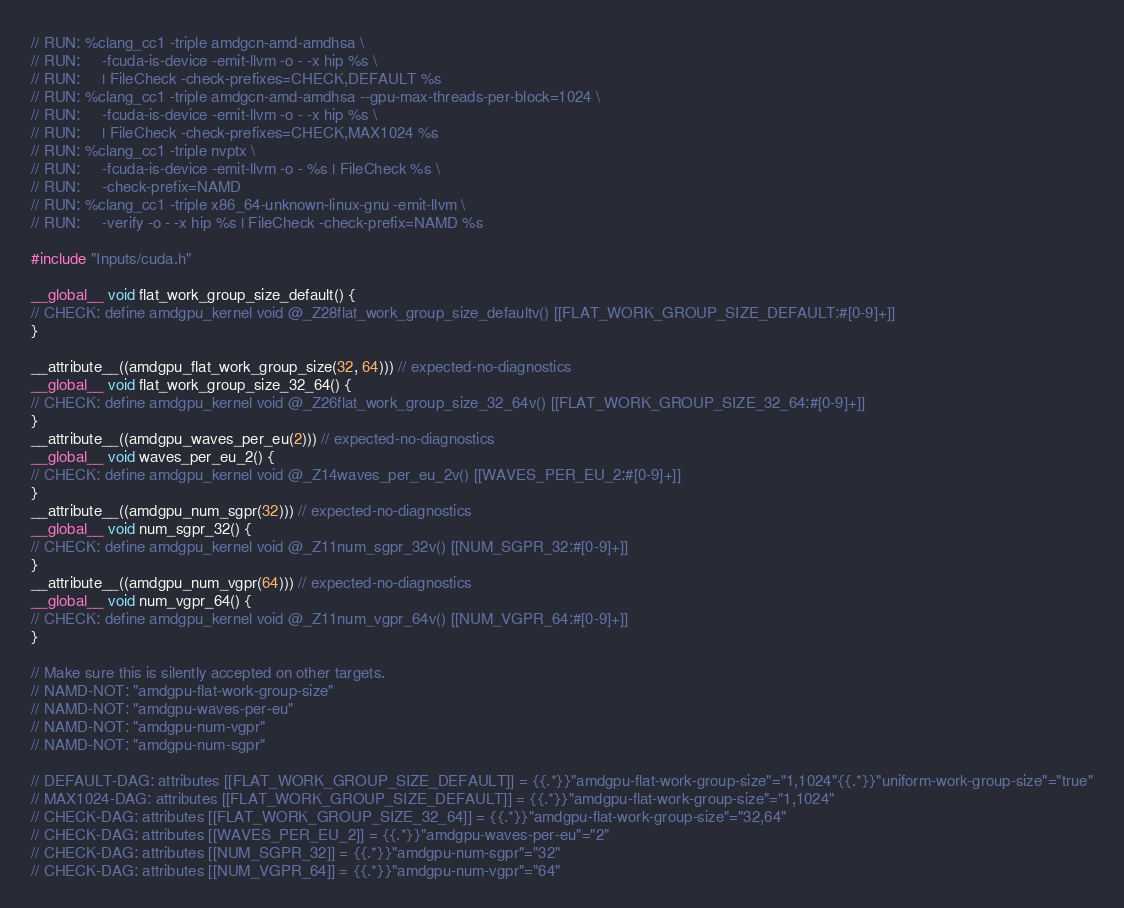<code> <loc_0><loc_0><loc_500><loc_500><_Cuda_>// RUN: %clang_cc1 -triple amdgcn-amd-amdhsa \
// RUN:     -fcuda-is-device -emit-llvm -o - -x hip %s \
// RUN:     | FileCheck -check-prefixes=CHECK,DEFAULT %s
// RUN: %clang_cc1 -triple amdgcn-amd-amdhsa --gpu-max-threads-per-block=1024 \
// RUN:     -fcuda-is-device -emit-llvm -o - -x hip %s \
// RUN:     | FileCheck -check-prefixes=CHECK,MAX1024 %s
// RUN: %clang_cc1 -triple nvptx \
// RUN:     -fcuda-is-device -emit-llvm -o - %s | FileCheck %s \
// RUN:     -check-prefix=NAMD
// RUN: %clang_cc1 -triple x86_64-unknown-linux-gnu -emit-llvm \
// RUN:     -verify -o - -x hip %s | FileCheck -check-prefix=NAMD %s

#include "Inputs/cuda.h"

__global__ void flat_work_group_size_default() {
// CHECK: define amdgpu_kernel void @_Z28flat_work_group_size_defaultv() [[FLAT_WORK_GROUP_SIZE_DEFAULT:#[0-9]+]]
}

__attribute__((amdgpu_flat_work_group_size(32, 64))) // expected-no-diagnostics
__global__ void flat_work_group_size_32_64() {
// CHECK: define amdgpu_kernel void @_Z26flat_work_group_size_32_64v() [[FLAT_WORK_GROUP_SIZE_32_64:#[0-9]+]]
}
__attribute__((amdgpu_waves_per_eu(2))) // expected-no-diagnostics
__global__ void waves_per_eu_2() {
// CHECK: define amdgpu_kernel void @_Z14waves_per_eu_2v() [[WAVES_PER_EU_2:#[0-9]+]]
}
__attribute__((amdgpu_num_sgpr(32))) // expected-no-diagnostics
__global__ void num_sgpr_32() {
// CHECK: define amdgpu_kernel void @_Z11num_sgpr_32v() [[NUM_SGPR_32:#[0-9]+]]
}
__attribute__((amdgpu_num_vgpr(64))) // expected-no-diagnostics
__global__ void num_vgpr_64() {
// CHECK: define amdgpu_kernel void @_Z11num_vgpr_64v() [[NUM_VGPR_64:#[0-9]+]]
}

// Make sure this is silently accepted on other targets.
// NAMD-NOT: "amdgpu-flat-work-group-size"
// NAMD-NOT: "amdgpu-waves-per-eu"
// NAMD-NOT: "amdgpu-num-vgpr"
// NAMD-NOT: "amdgpu-num-sgpr"

// DEFAULT-DAG: attributes [[FLAT_WORK_GROUP_SIZE_DEFAULT]] = {{.*}}"amdgpu-flat-work-group-size"="1,1024"{{.*}}"uniform-work-group-size"="true"
// MAX1024-DAG: attributes [[FLAT_WORK_GROUP_SIZE_DEFAULT]] = {{.*}}"amdgpu-flat-work-group-size"="1,1024"
// CHECK-DAG: attributes [[FLAT_WORK_GROUP_SIZE_32_64]] = {{.*}}"amdgpu-flat-work-group-size"="32,64"
// CHECK-DAG: attributes [[WAVES_PER_EU_2]] = {{.*}}"amdgpu-waves-per-eu"="2"
// CHECK-DAG: attributes [[NUM_SGPR_32]] = {{.*}}"amdgpu-num-sgpr"="32"
// CHECK-DAG: attributes [[NUM_VGPR_64]] = {{.*}}"amdgpu-num-vgpr"="64"
</code> 